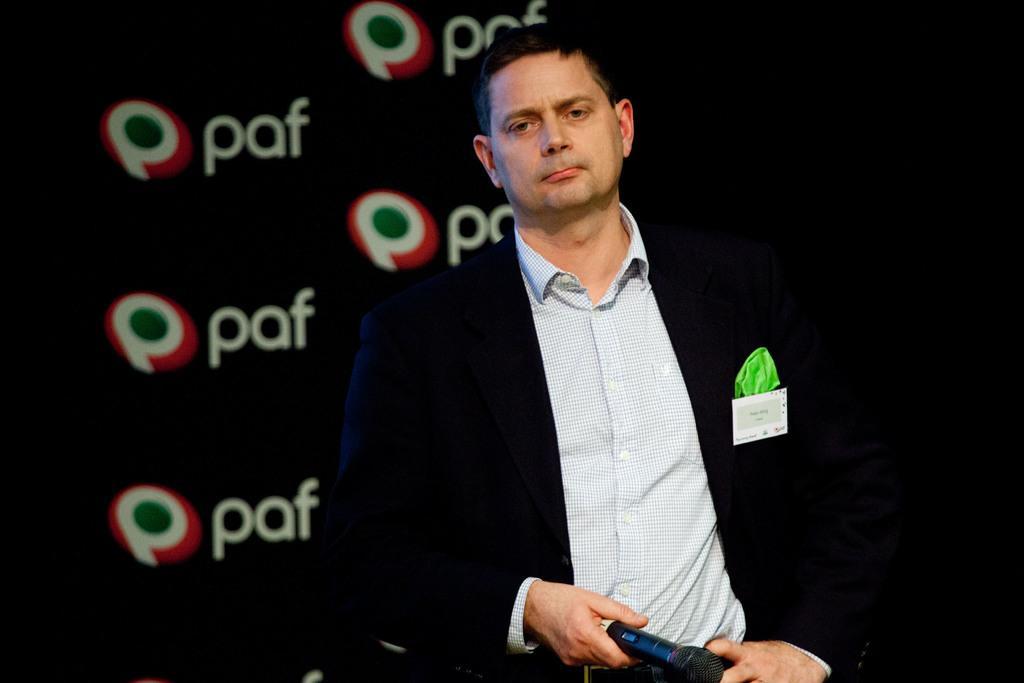Describe this image in one or two sentences. We can see in the image there is a man who is standing and he is holding a mike and behind him there is a black banner on which it's written "paf". 